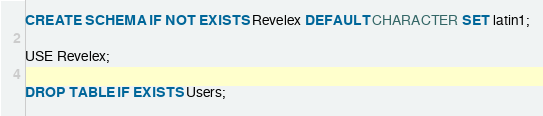<code> <loc_0><loc_0><loc_500><loc_500><_SQL_>CREATE SCHEMA IF NOT EXISTS Revelex DEFAULT CHARACTER SET latin1;

USE Revelex;

DROP TABLE IF EXISTS Users;
</code> 